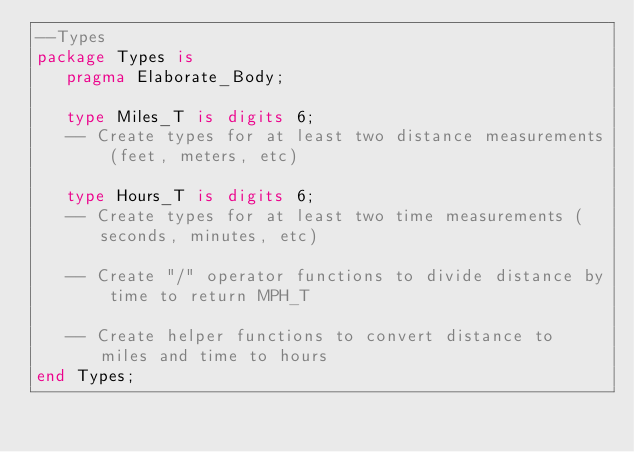Convert code to text. <code><loc_0><loc_0><loc_500><loc_500><_Ada_>--Types
package Types is
   pragma Elaborate_Body;

   type Miles_T is digits 6;
   -- Create types for at least two distance measurements (feet, meters, etc)

   type Hours_T is digits 6;
   -- Create types for at least two time measurements (seconds, minutes, etc)

   -- Create "/" operator functions to divide distance by time to return MPH_T

   -- Create helper functions to convert distance to miles and time to hours
end Types;
</code> 